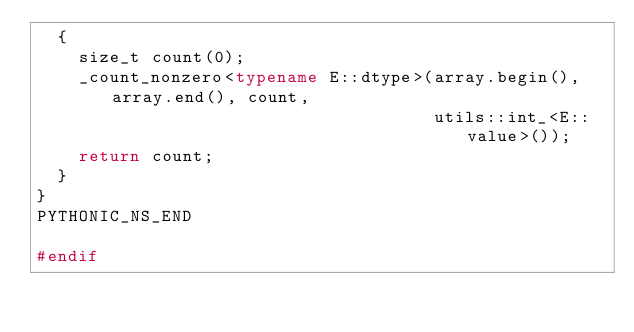Convert code to text. <code><loc_0><loc_0><loc_500><loc_500><_C++_>  {
    size_t count(0);
    _count_nonzero<typename E::dtype>(array.begin(), array.end(), count,
                                      utils::int_<E::value>());
    return count;
  }
}
PYTHONIC_NS_END

#endif
</code> 